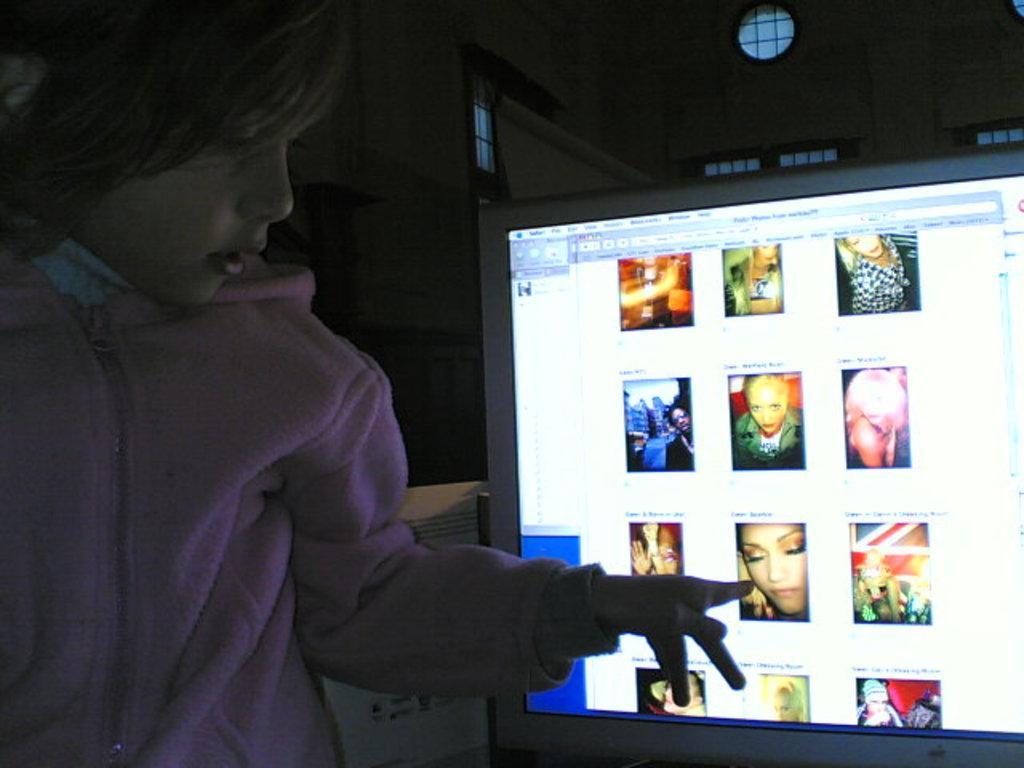How would you summarize this image in a sentence or two? In this picture there is a girl who is wearing pink hoodie. He is pointing out on computer screen. In the background we can see the windows and wall. In the screen we can see the persons photos. 